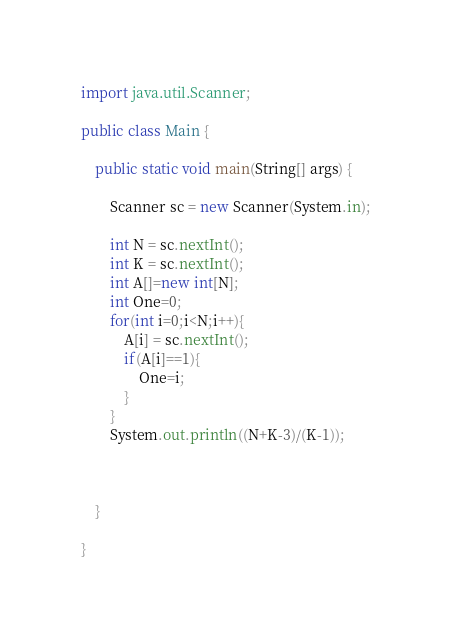<code> <loc_0><loc_0><loc_500><loc_500><_Java_>import java.util.Scanner;

public class Main {

	public static void main(String[] args) {

		Scanner sc = new Scanner(System.in);

		int N = sc.nextInt();
		int K = sc.nextInt();
		int A[]=new int[N];
		int One=0;
		for(int i=0;i<N;i++){
			A[i] = sc.nextInt();
			if(A[i]==1){
				One=i;
			}
		}
		System.out.println((N+K-3)/(K-1));



	}

}
</code> 